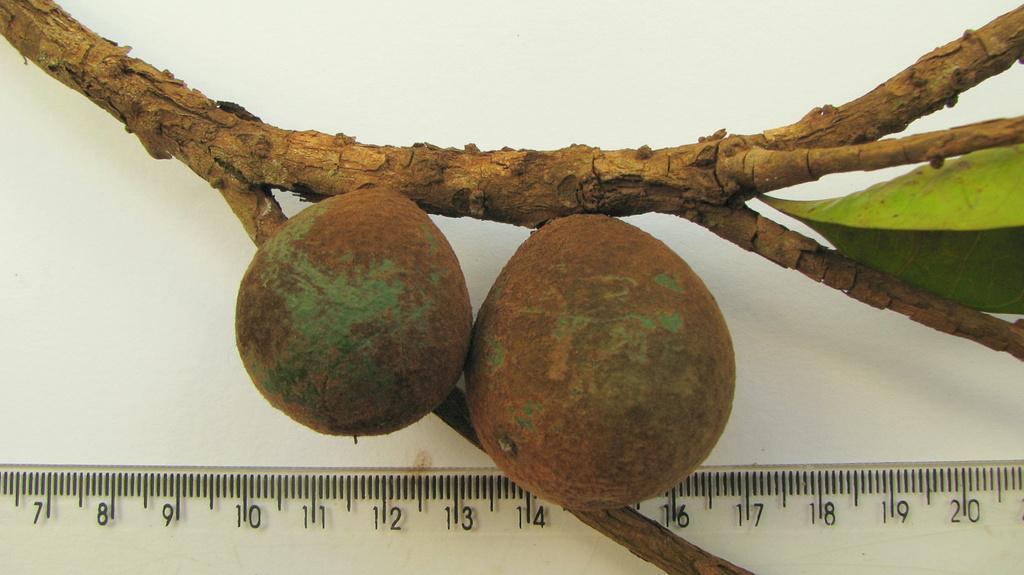Provide a one-sentence caption for the provided image. Two green and brown pear shaped fruits attached to a limb next to clear ruler measuring 3 and 3.75 inches. 